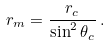Convert formula to latex. <formula><loc_0><loc_0><loc_500><loc_500>r _ { m } = \frac { r _ { c } } { \sin ^ { 2 } \theta _ { c } } \, .</formula> 